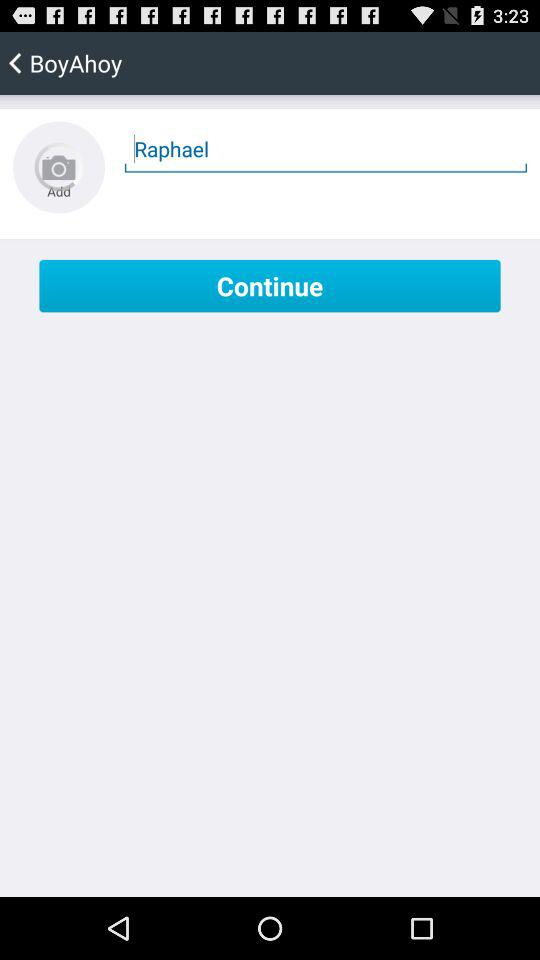What is the name of the user? The name of the user is Raphael. 